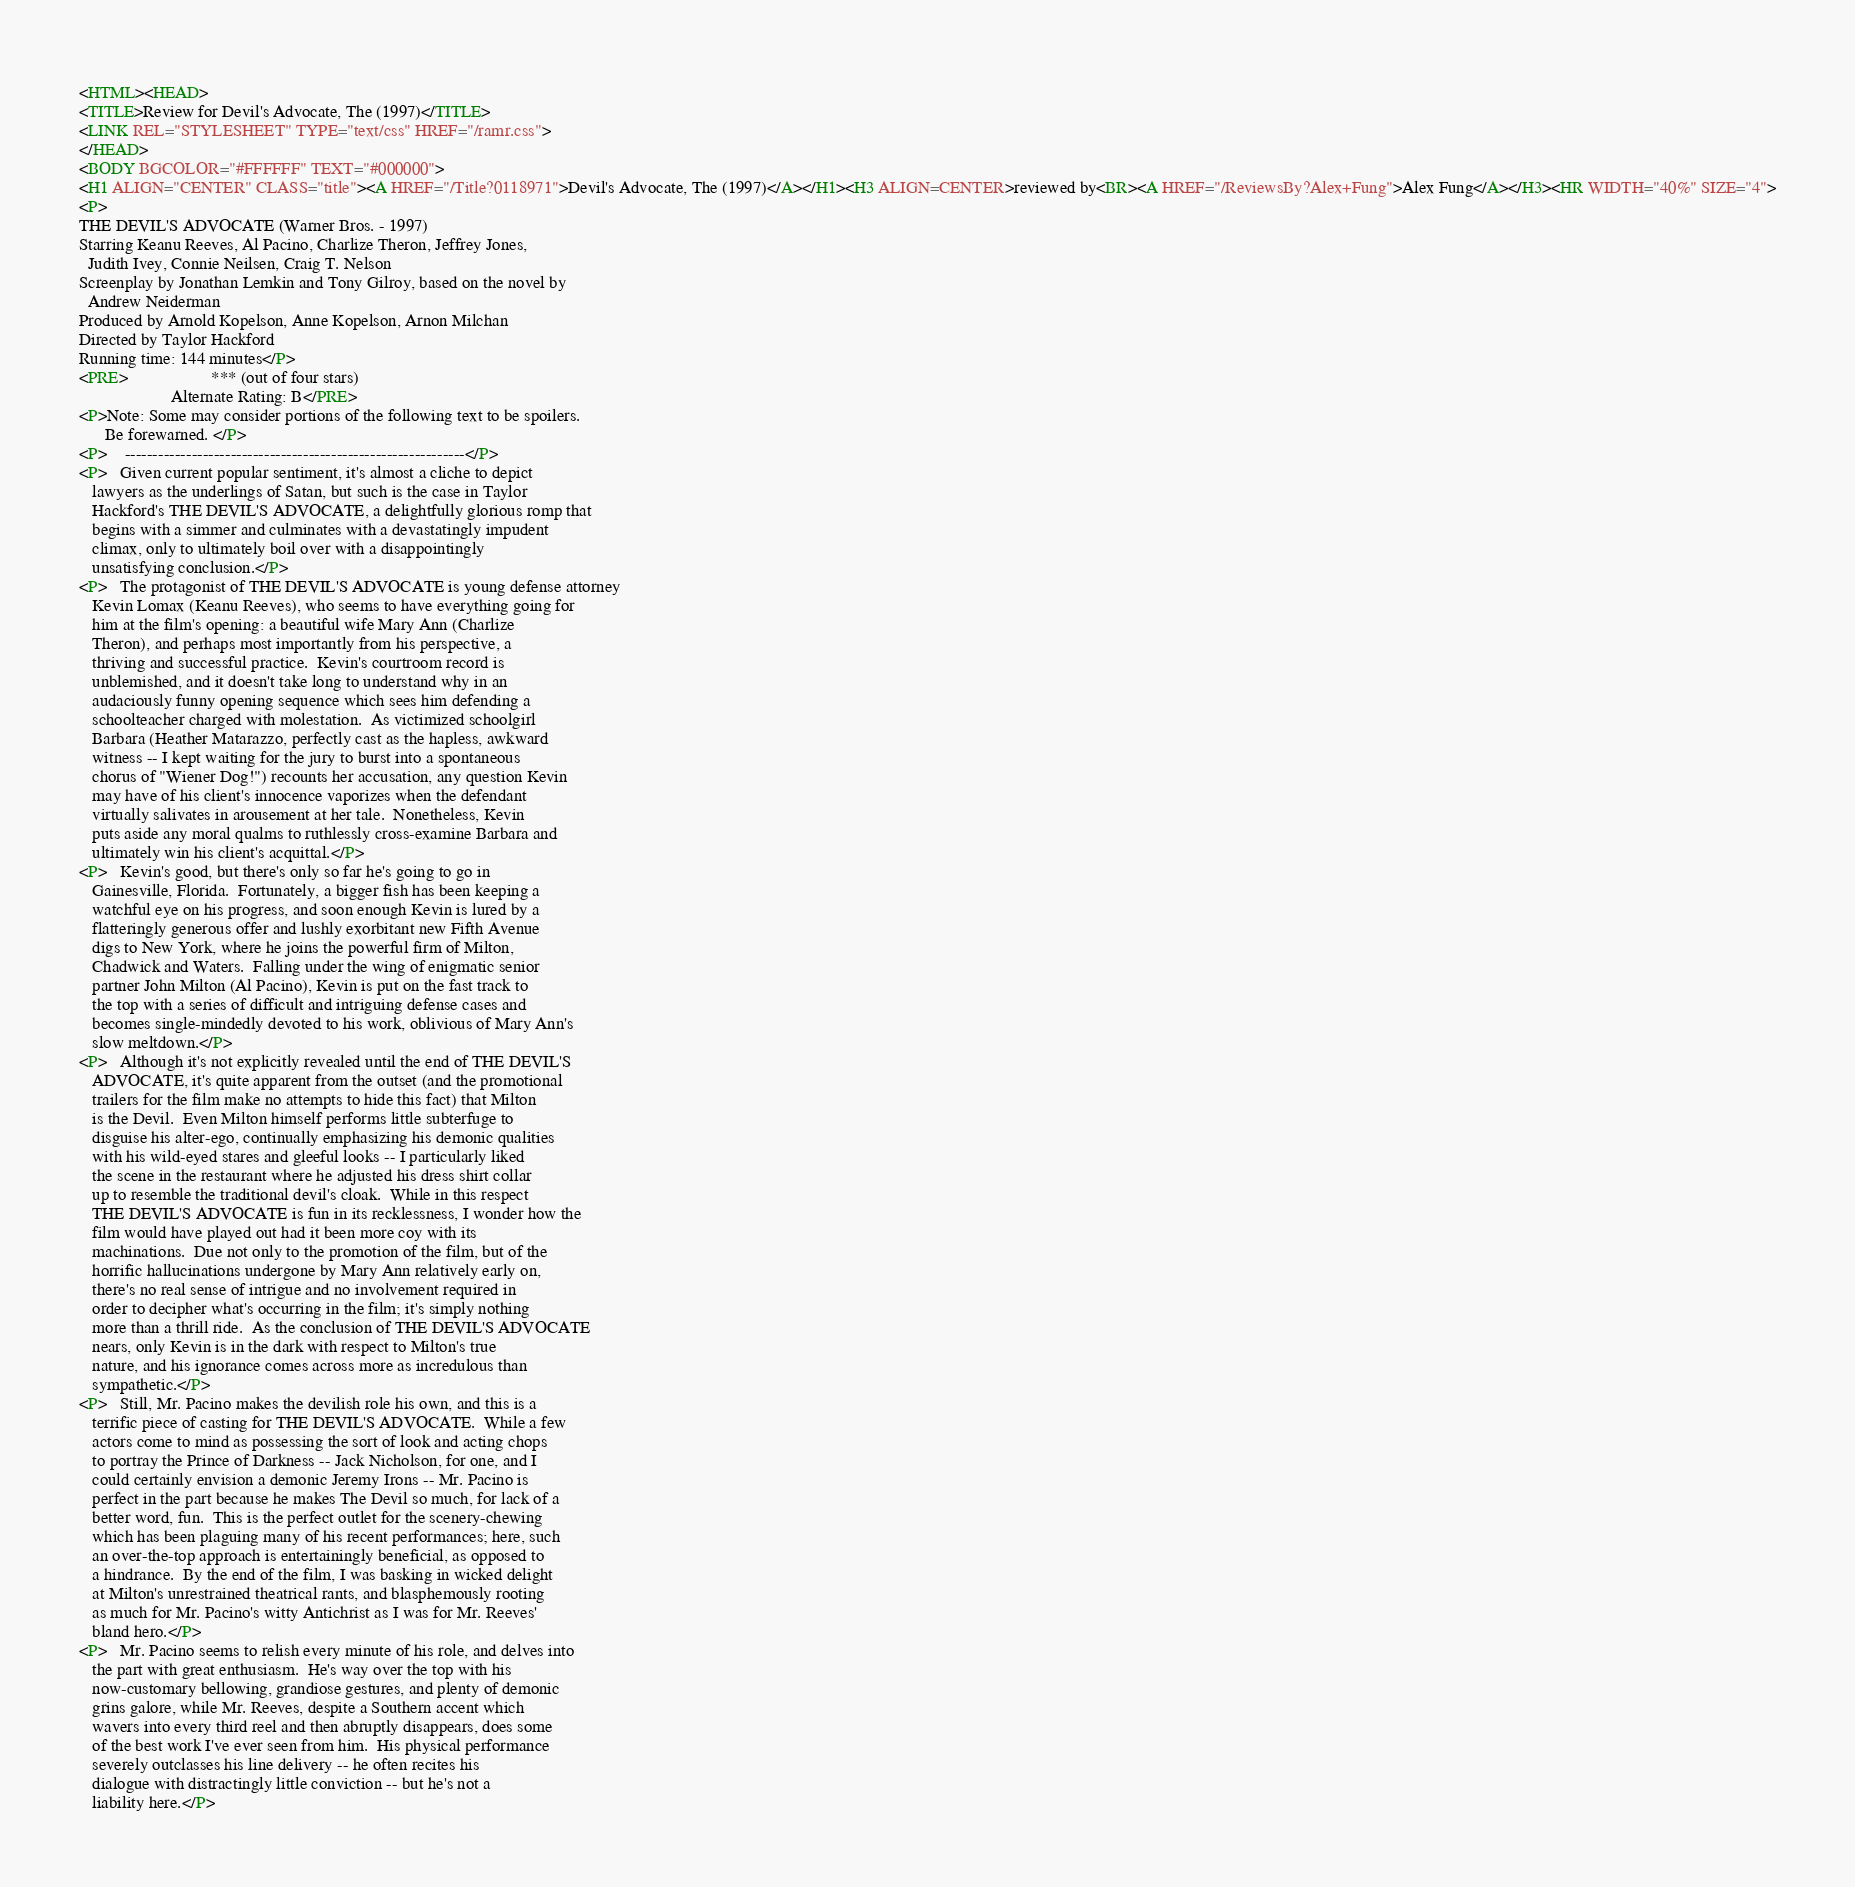Convert code to text. <code><loc_0><loc_0><loc_500><loc_500><_HTML_><HTML><HEAD>
<TITLE>Review for Devil's Advocate, The (1997)</TITLE>
<LINK REL="STYLESHEET" TYPE="text/css" HREF="/ramr.css">
</HEAD>
<BODY BGCOLOR="#FFFFFF" TEXT="#000000">
<H1 ALIGN="CENTER" CLASS="title"><A HREF="/Title?0118971">Devil's Advocate, The (1997)</A></H1><H3 ALIGN=CENTER>reviewed by<BR><A HREF="/ReviewsBy?Alex+Fung">Alex Fung</A></H3><HR WIDTH="40%" SIZE="4">
<P>
THE DEVIL'S ADVOCATE (Warner Bros. - 1997)
Starring Keanu Reeves, Al Pacino, Charlize Theron, Jeffrey Jones,
  Judith Ivey, Connie Neilsen, Craig T. Nelson
Screenplay by Jonathan Lemkin and Tony Gilroy, based on the novel by
  Andrew Neiderman
Produced by Arnold Kopelson, Anne Kopelson, Arnon Milchan
Directed by Taylor Hackford
Running time: 144 minutes</P>
<PRE>                   *** (out of four stars)
                     Alternate Rating: B</PRE>
<P>Note: Some may consider portions of the following text to be spoilers.
      Be forewarned. </P>
<P>    -------------------------------------------------------------</P>
<P>   Given current popular sentiment, it's almost a cliche to depict
   lawyers as the underlings of Satan, but such is the case in Taylor
   Hackford's THE DEVIL'S ADVOCATE, a delightfully glorious romp that
   begins with a simmer and culminates with a devastatingly impudent
   climax, only to ultimately boil over with a disappointingly
   unsatisfying conclusion.</P>
<P>   The protagonist of THE DEVIL'S ADVOCATE is young defense attorney
   Kevin Lomax (Keanu Reeves), who seems to have everything going for
   him at the film's opening: a beautiful wife Mary Ann (Charlize
   Theron), and perhaps most importantly from his perspective, a
   thriving and successful practice.  Kevin's courtroom record is
   unblemished, and it doesn't take long to understand why in an
   audaciously funny opening sequence which sees him defending a
   schoolteacher charged with molestation.  As victimized schoolgirl
   Barbara (Heather Matarazzo, perfectly cast as the hapless, awkward
   witness -- I kept waiting for the jury to burst into a spontaneous
   chorus of "Wiener Dog!") recounts her accusation, any question Kevin
   may have of his client's innocence vaporizes when the defendant
   virtually salivates in arousement at her tale.  Nonetheless, Kevin
   puts aside any moral qualms to ruthlessly cross-examine Barbara and
   ultimately win his client's acquittal.</P>
<P>   Kevin's good, but there's only so far he's going to go in
   Gainesville, Florida.  Fortunately, a bigger fish has been keeping a
   watchful eye on his progress, and soon enough Kevin is lured by a
   flatteringly generous offer and lushly exorbitant new Fifth Avenue
   digs to New York, where he joins the powerful firm of Milton,
   Chadwick and Waters.  Falling under the wing of enigmatic senior
   partner John Milton (Al Pacino), Kevin is put on the fast track to
   the top with a series of difficult and intriguing defense cases and
   becomes single-mindedly devoted to his work, oblivious of Mary Ann's
   slow meltdown.</P>
<P>   Although it's not explicitly revealed until the end of THE DEVIL'S
   ADVOCATE, it's quite apparent from the outset (and the promotional
   trailers for the film make no attempts to hide this fact) that Milton
   is the Devil.  Even Milton himself performs little subterfuge to
   disguise his alter-ego, continually emphasizing his demonic qualities
   with his wild-eyed stares and gleeful looks -- I particularly liked
   the scene in the restaurant where he adjusted his dress shirt collar
   up to resemble the traditional devil's cloak.  While in this respect
   THE DEVIL'S ADVOCATE is fun in its recklessness, I wonder how the
   film would have played out had it been more coy with its
   machinations.  Due not only to the promotion of the film, but of the
   horrific hallucinations undergone by Mary Ann relatively early on,
   there's no real sense of intrigue and no involvement required in
   order to decipher what's occurring in the film; it's simply nothing
   more than a thrill ride.  As the conclusion of THE DEVIL'S ADVOCATE
   nears, only Kevin is in the dark with respect to Milton's true
   nature, and his ignorance comes across more as incredulous than
   sympathetic.</P>
<P>   Still, Mr. Pacino makes the devilish role his own, and this is a
   terrific piece of casting for THE DEVIL'S ADVOCATE.  While a few
   actors come to mind as possessing the sort of look and acting chops
   to portray the Prince of Darkness -- Jack Nicholson, for one, and I
   could certainly envision a demonic Jeremy Irons -- Mr. Pacino is
   perfect in the part because he makes The Devil so much, for lack of a
   better word, fun.  This is the perfect outlet for the scenery-chewing
   which has been plaguing many of his recent performances; here, such
   an over-the-top approach is entertainingly beneficial, as opposed to
   a hindrance.  By the end of the film, I was basking in wicked delight
   at Milton's unrestrained theatrical rants, and blasphemously rooting
   as much for Mr. Pacino's witty Antichrist as I was for Mr. Reeves'
   bland hero.</P>
<P>   Mr. Pacino seems to relish every minute of his role, and delves into
   the part with great enthusiasm.  He's way over the top with his
   now-customary bellowing, grandiose gestures, and plenty of demonic
   grins galore, while Mr. Reeves, despite a Southern accent which
   wavers into every third reel and then abruptly disappears, does some
   of the best work I've ever seen from him.  His physical performance
   severely outclasses his line delivery -- he often recites his
   dialogue with distractingly little conviction -- but he's not a
   liability here.</P></code> 